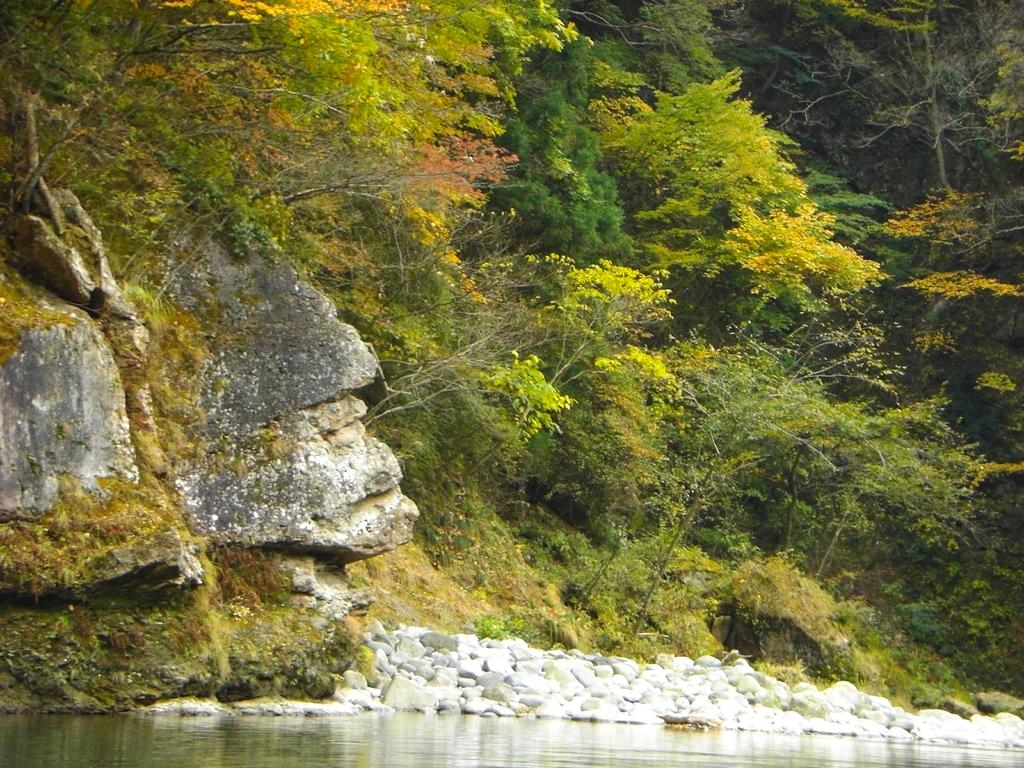What type of natural elements can be seen in the image? There are trees, rocks, and water visible in the image. Can you describe the landscape in the image? The image features a landscape with trees, rocks, and water. What might be the setting of this image? The image could be set in a natural environment, such as a park or a riverbank. What is the desire of the rocks in the image? There is no indication of desire or emotion in the image, as rocks are inanimate objects. 